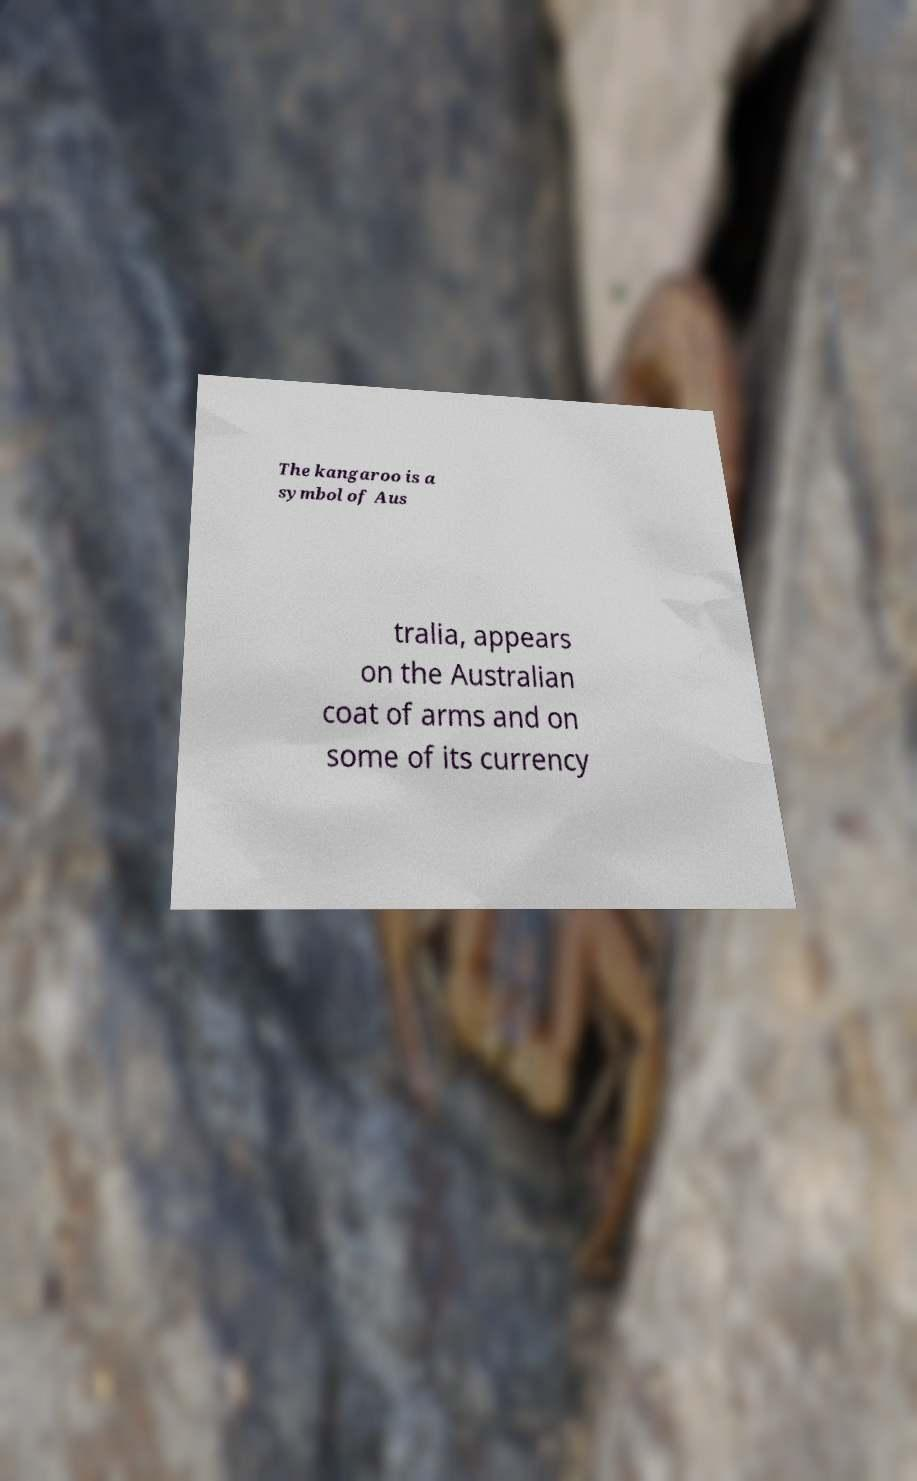Can you accurately transcribe the text from the provided image for me? The kangaroo is a symbol of Aus tralia, appears on the Australian coat of arms and on some of its currency 